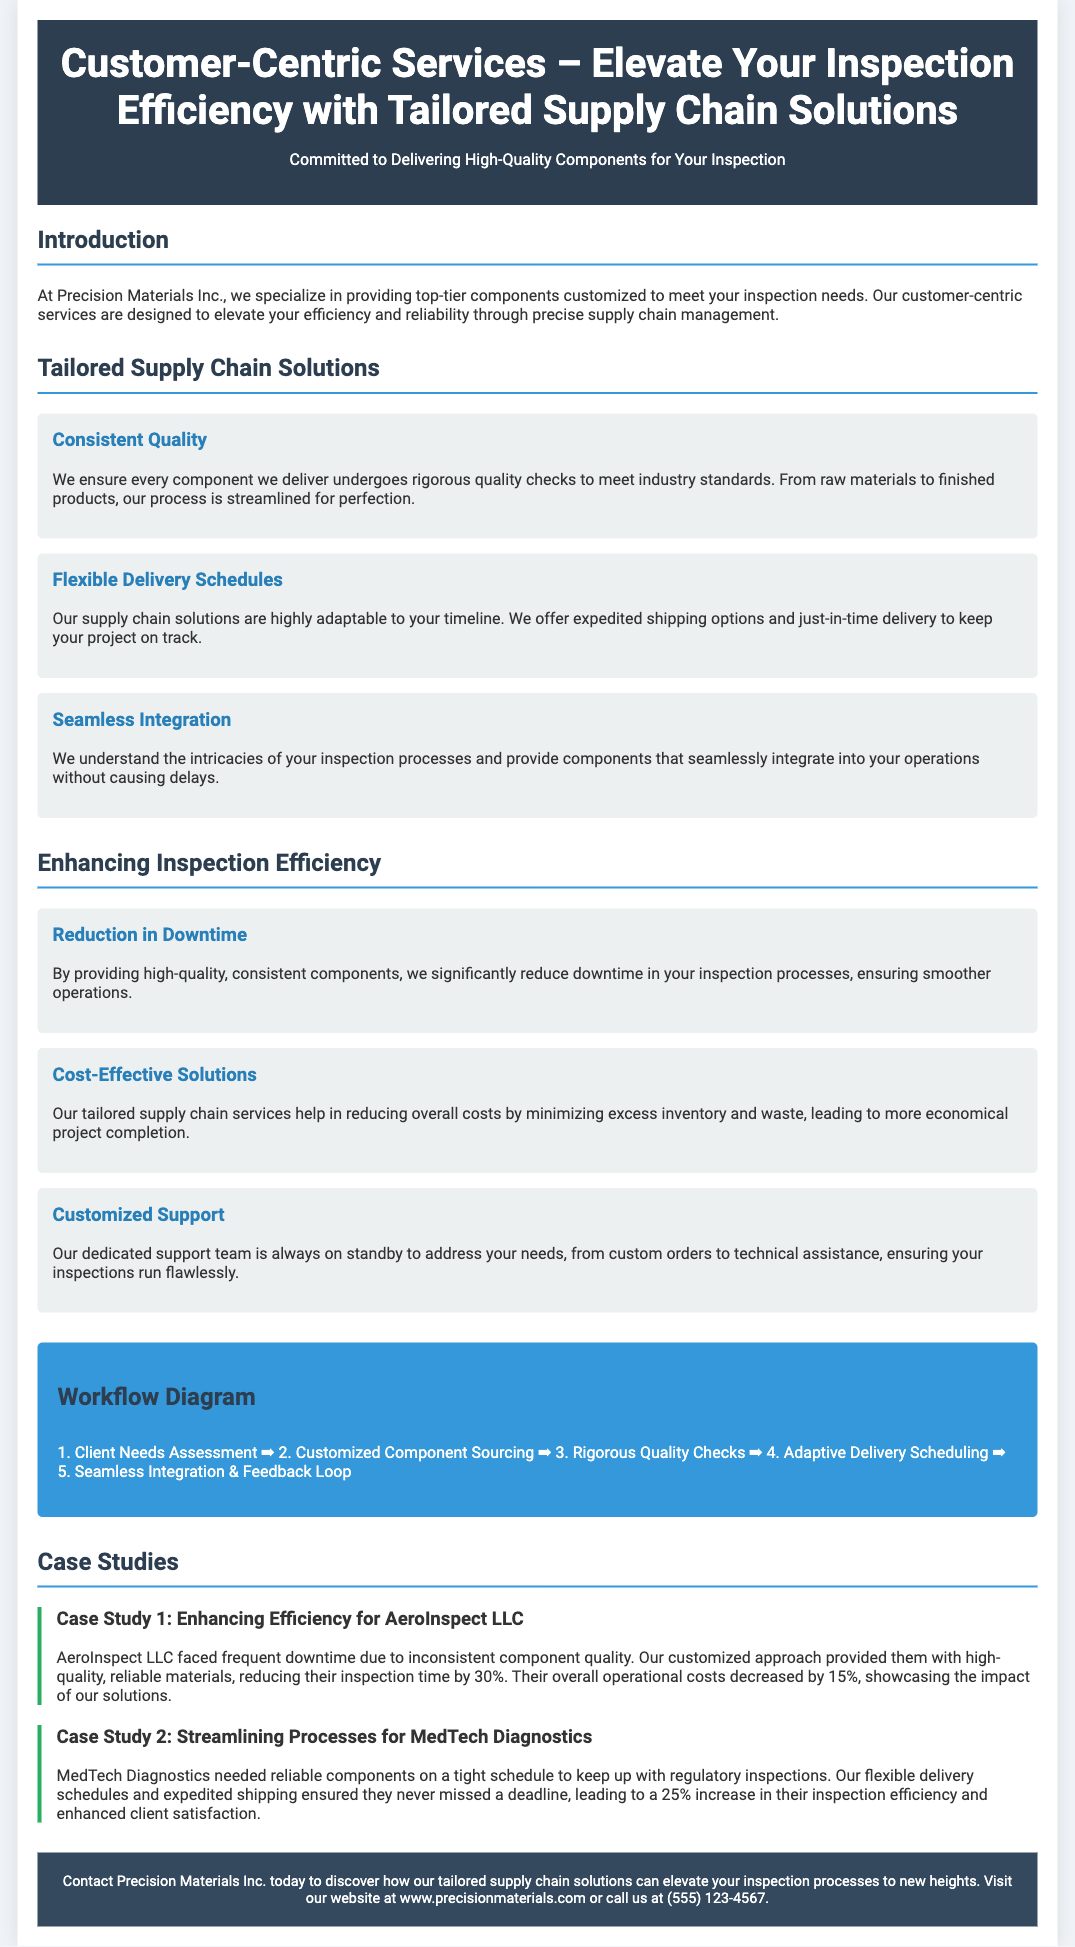what is the company name? The company name is mentioned in the title and throughout the document.
Answer: Precision Materials Inc what is the main focus of Precision Materials Inc.? The focus is indicated in the introduction and the header of the document.
Answer: Customer-Centric Services how much did operational costs decrease for AeroInspect LLC? The decrease in operational costs is stated under the case study for AeroInspect LLC.
Answer: 15% what is the workflow diagram’s first step? The first step is listed at the top of the workflow diagram section.
Answer: Client Needs Assessment what percentage increase in inspection efficiency did MedTech Diagnostics achieve? This percentage is detailed in the case study for MedTech Diagnostics.
Answer: 25% what type of support does Precision Materials Inc. offer? The type of support is described in the section on enhancing inspection efficiency.
Answer: Customized Support how does Precision Materials Inc. ensure consistent quality? The method for ensuring quality is described in the tailored supply chain solutions section.
Answer: Rigorous quality checks what is the title of the first case study? The title is provided in the header of the case study section.
Answer: Case Study 1: Enhancing Efficiency for AeroInspect LLC what aspect of delivery is emphasized in the flyer? The emphasized aspect is included in the section discussing tailored supply chain solutions.
Answer: Flexible Delivery Schedules 